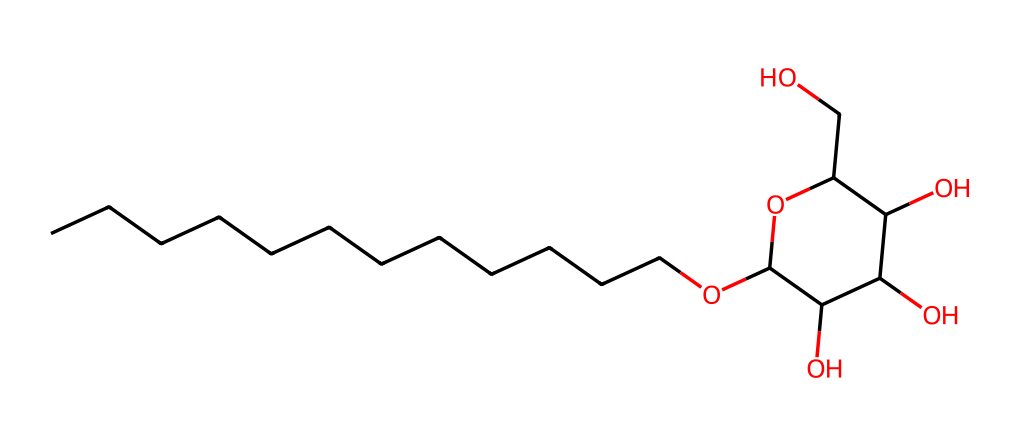What is the carbon chain length of the alkyl portion in this surfactant? The SMILES representation starts with 'CCCCCCCCCCCC', indicating a continuous chain of 12 carbon atoms (C). Each 'C' in the sequence represents one carbon atom, which confirms the length.
Answer: 12 How many hydroxyl groups are present in the structure? The hydroxyl groups are indicated by the 'O' connected to the carbon atoms within the structure. Counting the 'O' atoms directly from the SMILES reveals there are 5 hydroxyl groups present.
Answer: 5 What type of linkage connects the alkyl chain to the sugar moiety? The connection between the alkyl chain and the sugar component is characterized by an ether bond, as indicated by the 'O' in the SMILES following the alkyl chain. This represents an ether linkage typical in surfactants.
Answer: ether Which structural part enhances the surfactant's hydrophilicity? The sugar moiety, due to the presence of multiple hydroxyl (OH) groups, increases hydrophilicity. These hydroxyl groups can interact favorably with water, making the molecule more soluble in aqueous environments.
Answer: sugar moiety What is the overall charge of this surfactant under normal conditions? By analyzing the structure, it appears there are no permanent ionic groups, leading to a neutral charge overall. The molecular structure does not contain any charged functional groups.
Answer: neutral What characteristic allows this surfactant to be biodegradable? The presence of sugar units and hydroxyl groups contributes to the ability of microorganisms to break down this surfactant through enzymatic action. This carbohydrate-based structure is generally more amenable to microbial degradation compared to synthetic surfactants.
Answer: carbohydrate-based structure 